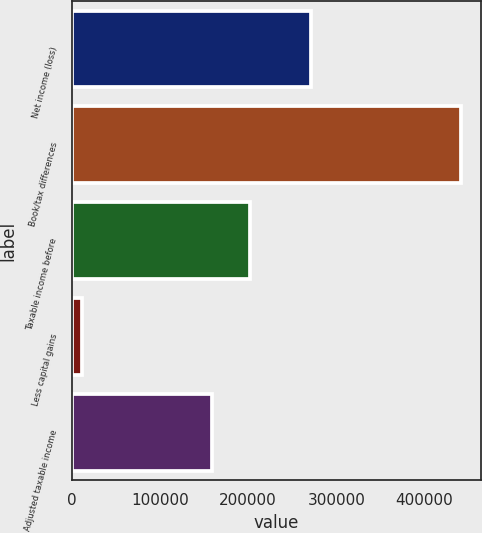Convert chart. <chart><loc_0><loc_0><loc_500><loc_500><bar_chart><fcel>Net income (loss)<fcel>Book/tax differences<fcel>Taxable income before<fcel>Less capital gains<fcel>Adjusted taxable income<nl><fcel>271490<fcel>441784<fcel>202562<fcel>10828<fcel>159466<nl></chart> 